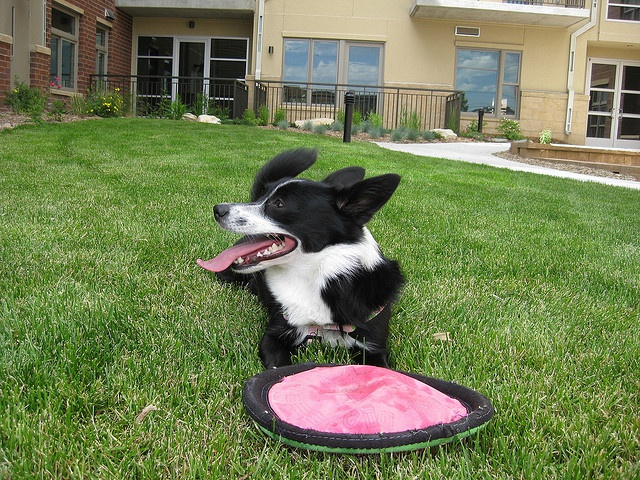Describe the objects in this image and their specific colors. I can see dog in gray, black, lightgray, and darkgray tones and frisbee in gray, lightpink, and black tones in this image. 